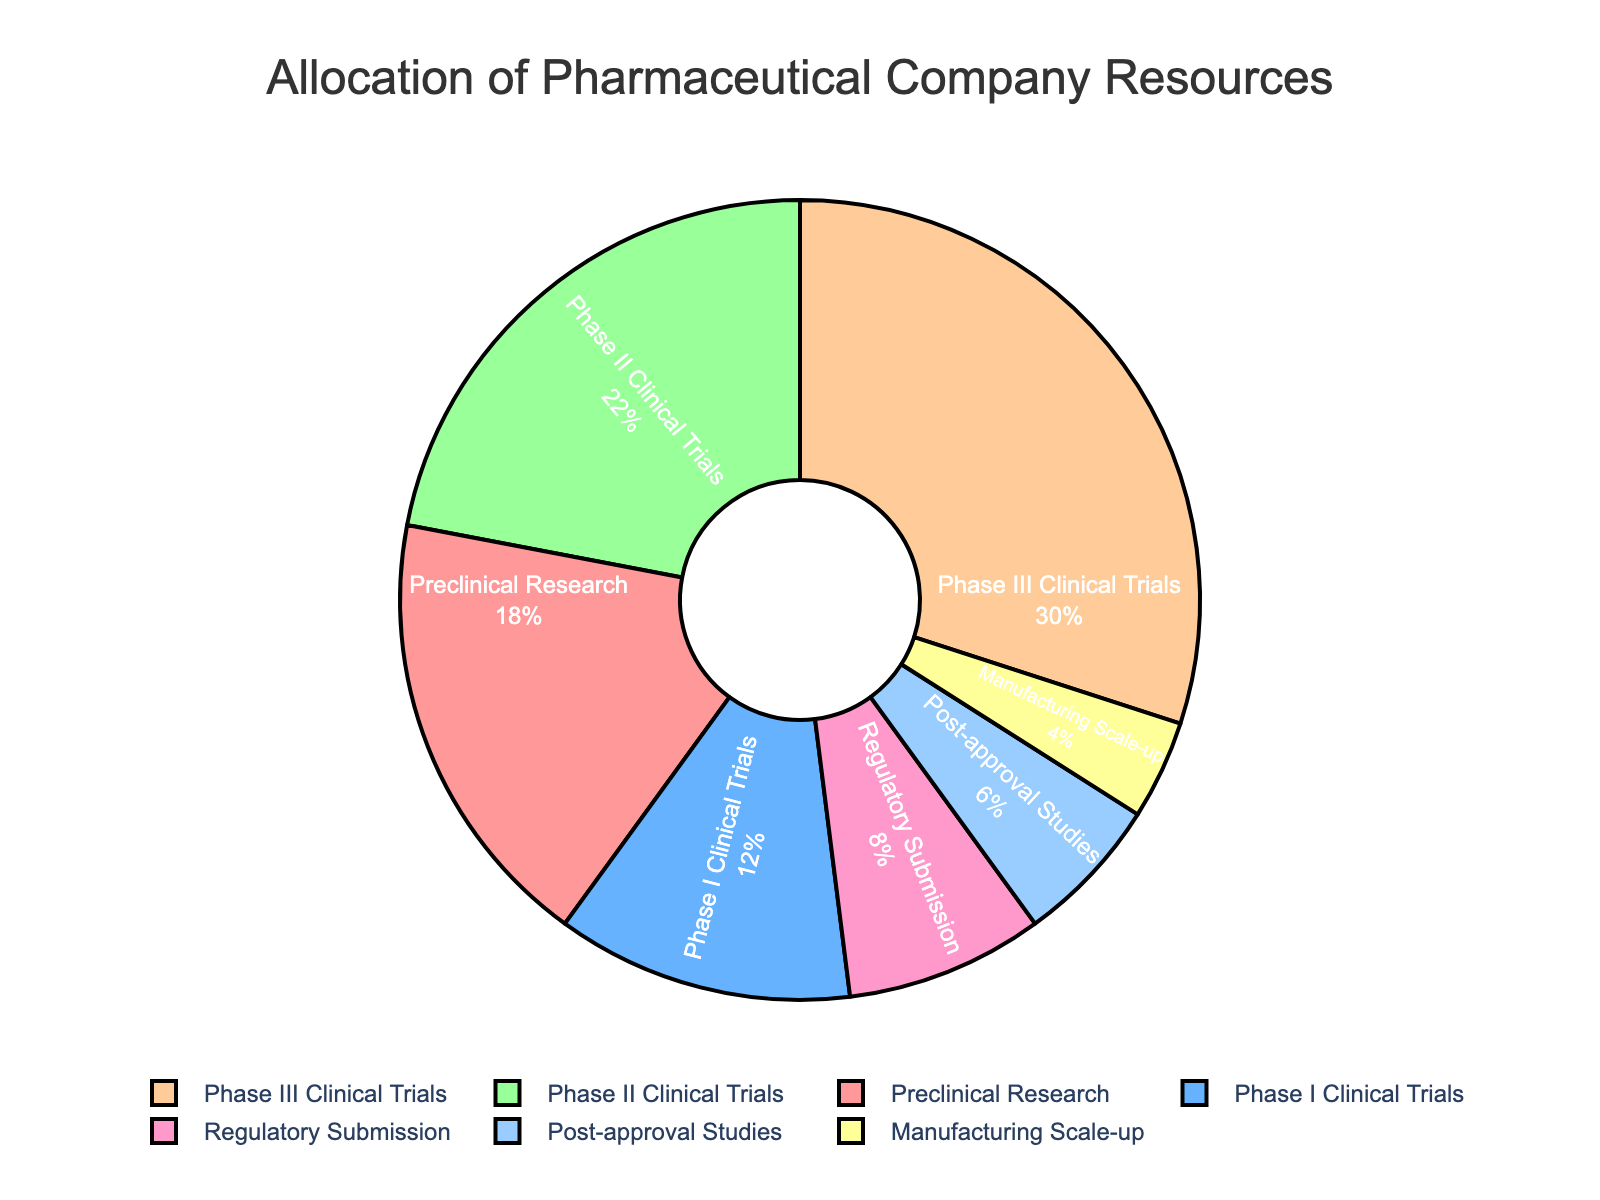Which phase receives the highest allocation of resources? The figure shows the percentage allocation for each phase, and Phase III Clinical Trials have the largest portion.
Answer: Phase III Clinical Trials What is the total percentage of resources allocated to both Phase I and Phase II Clinical Trials combined? Add the percentages of Phase I Clinical Trials (12%) and Phase II Clinical Trials (22%). The sum is 12 + 22 = 34%.
Answer: 34% Which phase gets double the resources as Manufacturing Scale-up? Manufacturing Scale-up has a 4% allocation. The phase that gets double that would be 4% * 2 = 8%. This corresponds to Regulatory Submission.
Answer: Regulatory Submission What is the difference in resource allocation between Preclinical Research and Post-approval Studies? Subtract the percentage for Post-approval Studies (6%) from Preclinical Research (18%). The difference is 18 - 6 = 12%.
Answer: 12% Which phases receive less than 10% of the total resources? Based on the figure, the phases getting less than 10% of the resources are Regulatory Submission (8%), Post-approval Studies (6%), and Manufacturing Scale-up (4%).
Answer: Regulatory Submission, Post-approval Studies, Manufacturing Scale-up How much more in percentage is allocated to Phase III Clinical Trials compared to Phase I Clinical Trials? Subtract the percentage for Phase I Clinical Trials (12%) from Phase III Clinical Trials (30%). The difference is 30 - 12 = 18%.
Answer: 18% What is the average allocation of resources for all the listed phases? Sum up all the percentages and divide by the number of phases. (18 + 12 + 22 + 30 + 8 + 6 + 4) / 7 = 100 / 7 ≈ 14.29%.
Answer: 14.29% Which phase has the smallest allocation of resources? The figure shows each phase's allocation, and Manufacturing Scale-up has the smallest portion with only 4%.
Answer: Manufacturing Scale-up If you combine the resources allocated to Post-approval Studies and Regulatory Submission, what is their total allocation? Add the percentages of Post-approval Studies (6%) and Regulatory Submission (8%). The sum is 6 + 8 = 14%.
Answer: 14% Which phases have a combined allocation of 52%? Add the percentages of Phase II Clinical Trials (22%) and Phase III Clinical Trials (30%). The sum is 22 + 30 = 52%.
Answer: Phase II Clinical Trials, Phase III Clinical Trials 